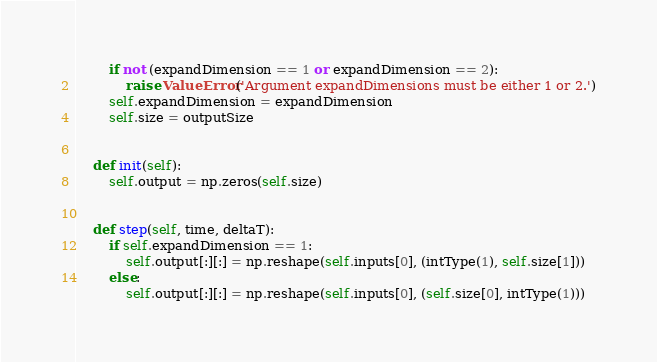Convert code to text. <code><loc_0><loc_0><loc_500><loc_500><_Python_>        if not (expandDimension == 1 or expandDimension == 2):
            raise ValueError('Argument expandDimensions must be either 1 or 2.')
        self.expandDimension = expandDimension
        self.size = outputSize


    def init(self):
        self.output = np.zeros(self.size)


    def step(self, time, deltaT):
        if self.expandDimension == 1:
            self.output[:][:] = np.reshape(self.inputs[0], (intType(1), self.size[1]))
        else:
            self.output[:][:] = np.reshape(self.inputs[0], (self.size[0], intType(1)))

</code> 